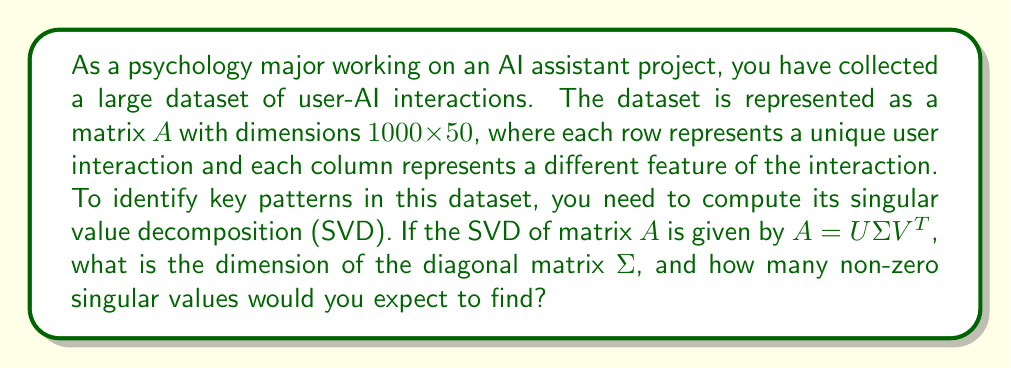Can you answer this question? To solve this problem, let's break it down step by step:

1. Understanding the matrix dimensions:
   - Matrix $A$ has dimensions $1000 \times 50$
   - $m = 1000$ (number of rows)
   - $n = 50$ (number of columns)

2. Recall the properties of SVD:
   - For a matrix $A_{m \times n}$, SVD decomposes it into $A = U\Sigma V^T$
   - $U$ is an $m \times m$ orthogonal matrix
   - $V^T$ is the transpose of an $n \times n$ orthogonal matrix
   - $\Sigma$ is an $m \times n$ diagonal matrix containing the singular values

3. Determine the dimension of $\Sigma$:
   - $\Sigma$ has the same dimensions as $A$
   - Therefore, $\Sigma$ is a $1000 \times 50$ matrix

4. Calculating the number of non-zero singular values:
   - The number of non-zero singular values is equal to the rank of the matrix
   - The maximum possible rank of a matrix is the minimum of its dimensions
   - $rank(A) \leq min(m, n) = min(1000, 50) = 50$

5. Consider the nature of the data:
   - In real-world datasets, especially with user-AI interactions, it's unlikely that all 50 features are linearly independent
   - Some features may be correlated or redundant
   - We can expect the actual rank to be less than 50, but the exact number depends on the specific dataset

Therefore, we can conclude that the dimension of $\Sigma$ is $1000 \times 50$, and we would expect to find at most 50 non-zero singular values, but likely fewer due to potential correlations in the data.
Answer: The diagonal matrix $\Sigma$ has dimensions $1000 \times 50$. We would expect to find at most 50 non-zero singular values, but likely fewer due to potential correlations in the user-AI interaction data. 